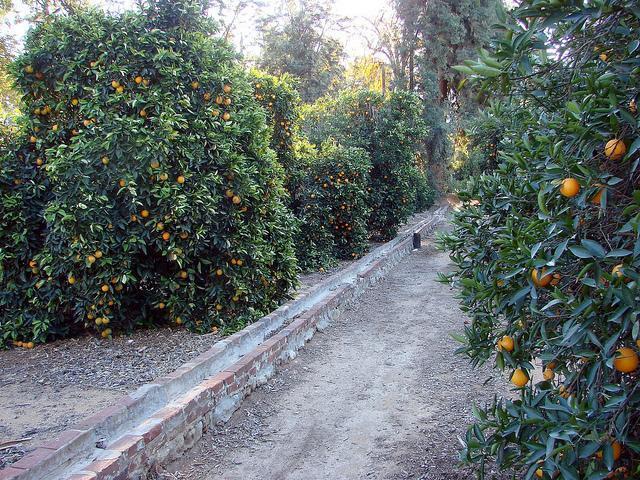How many oranges are in the picture?
Give a very brief answer. 1. 